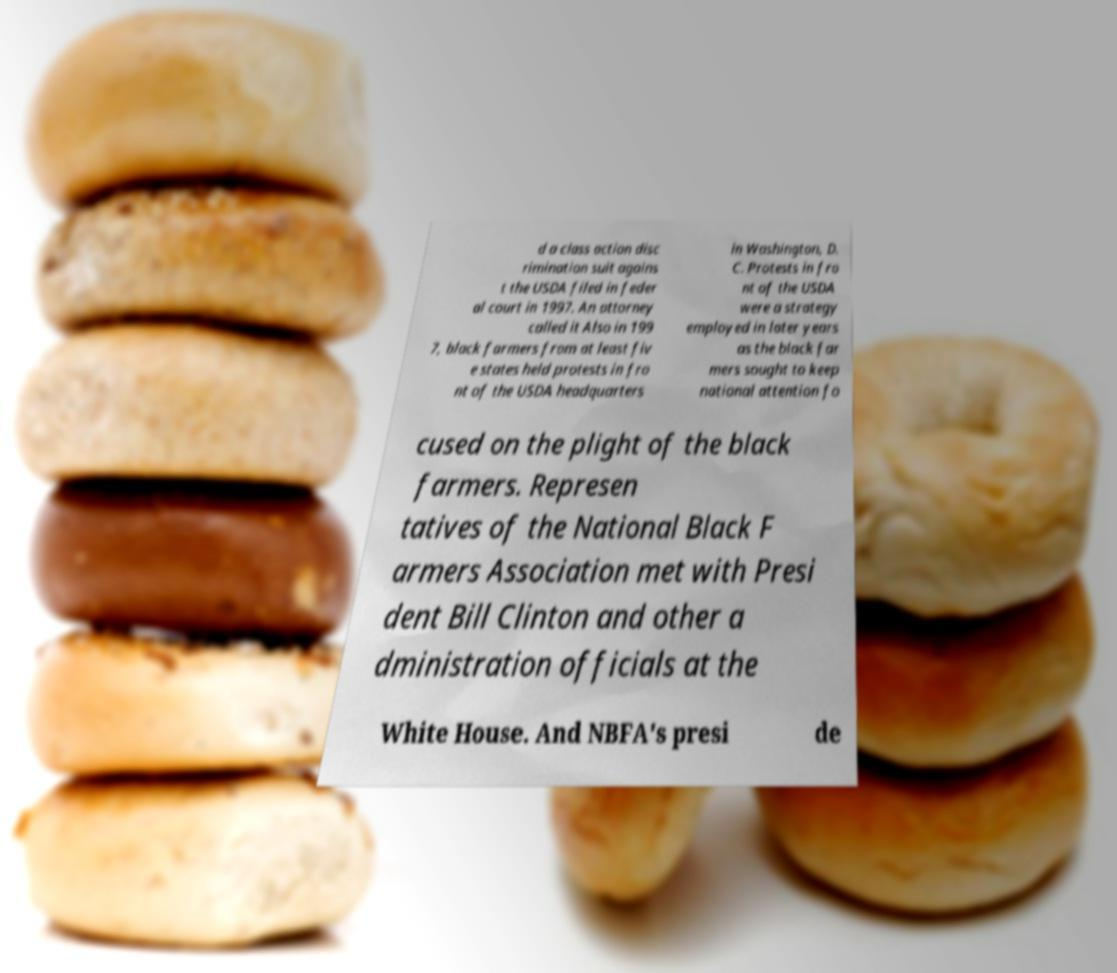I need the written content from this picture converted into text. Can you do that? d a class action disc rimination suit agains t the USDA filed in feder al court in 1997. An attorney called it Also in 199 7, black farmers from at least fiv e states held protests in fro nt of the USDA headquarters in Washington, D. C. Protests in fro nt of the USDA were a strategy employed in later years as the black far mers sought to keep national attention fo cused on the plight of the black farmers. Represen tatives of the National Black F armers Association met with Presi dent Bill Clinton and other a dministration officials at the White House. And NBFA's presi de 